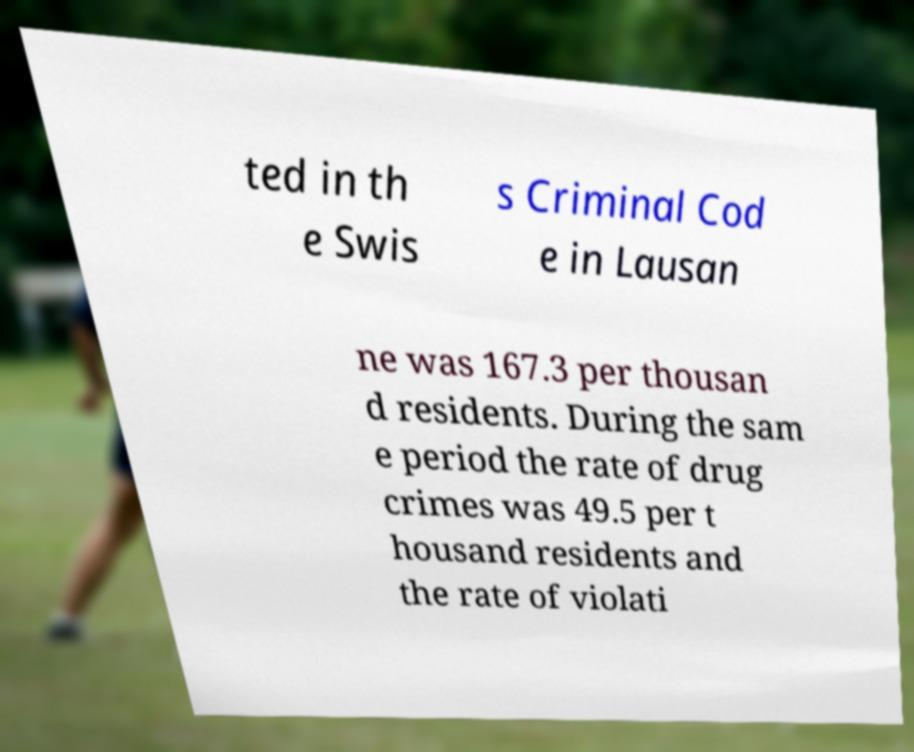What messages or text are displayed in this image? I need them in a readable, typed format. ted in th e Swis s Criminal Cod e in Lausan ne was 167.3 per thousan d residents. During the sam e period the rate of drug crimes was 49.5 per t housand residents and the rate of violati 